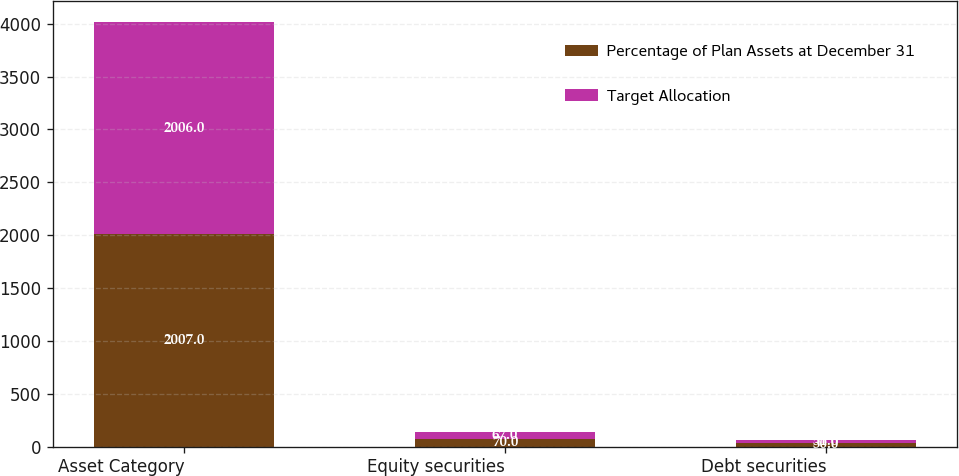Convert chart. <chart><loc_0><loc_0><loc_500><loc_500><stacked_bar_chart><ecel><fcel>Asset Category<fcel>Equity securities<fcel>Debt securities<nl><fcel>Percentage of Plan Assets at December 31<fcel>2007<fcel>70<fcel>30<nl><fcel>Target Allocation<fcel>2006<fcel>67<fcel>31<nl></chart> 